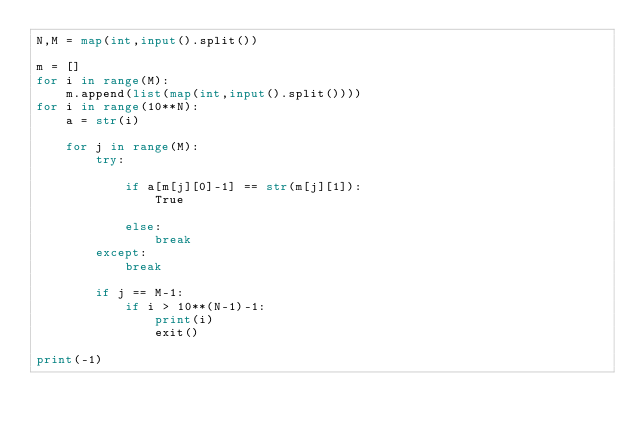Convert code to text. <code><loc_0><loc_0><loc_500><loc_500><_Python_>N,M = map(int,input().split())
 
m = []
for i in range(M):
    m.append(list(map(int,input().split())))
for i in range(10**N):
    a = str(i)
    
    for j in range(M):
        try:
            
            if a[m[j][0]-1] == str(m[j][1]):
                True
            
            else:
                break
        except:
            break
            
        if j == M-1:
            if i > 10**(N-1)-1:
                print(i)
                exit()
            
print(-1)</code> 